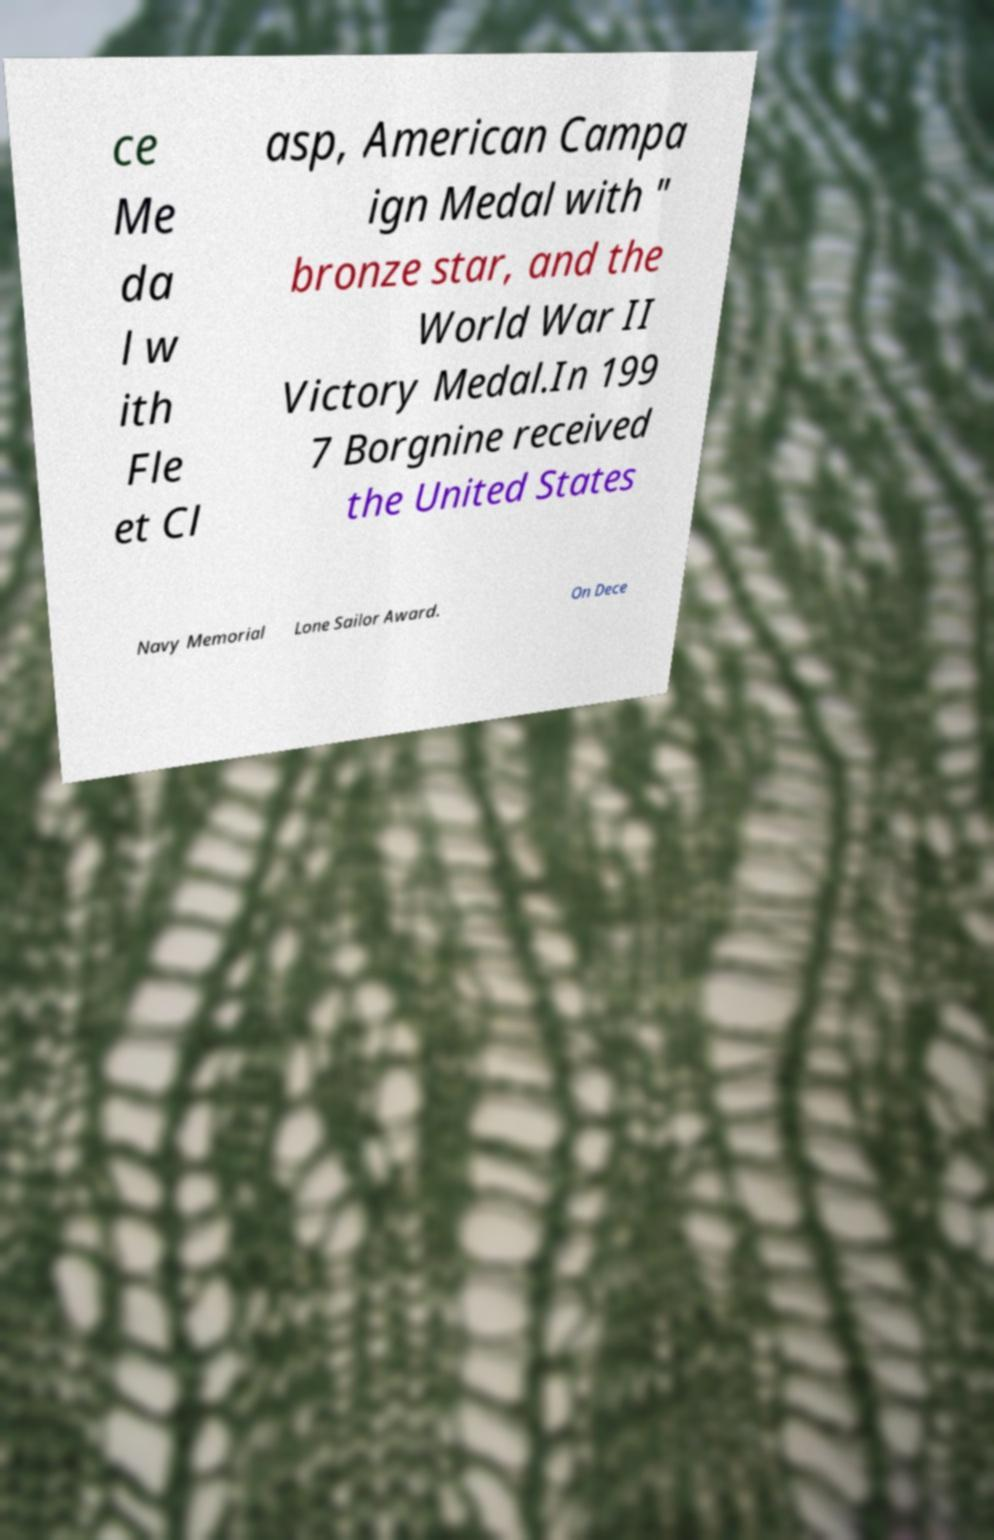Can you read and provide the text displayed in the image?This photo seems to have some interesting text. Can you extract and type it out for me? ce Me da l w ith Fle et Cl asp, American Campa ign Medal with " bronze star, and the World War II Victory Medal.In 199 7 Borgnine received the United States Navy Memorial Lone Sailor Award. On Dece 